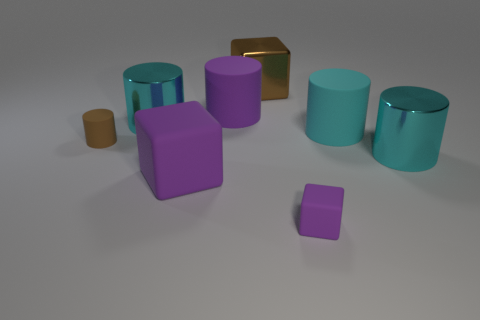How many cyan cylinders have the same material as the big brown thing?
Provide a succinct answer. 2. How many blue shiny things are there?
Keep it short and to the point. 0. Is the size of the shiny cube the same as the shiny thing that is in front of the tiny brown rubber cylinder?
Provide a short and direct response. Yes. There is a tiny thing behind the large object that is right of the big cyan rubber cylinder; what is its material?
Make the answer very short. Rubber. How big is the brown object that is to the right of the small object that is left of the shiny thing left of the brown metal block?
Give a very brief answer. Large. Do the tiny purple matte object and the big rubber object that is in front of the small brown matte object have the same shape?
Your answer should be compact. Yes. What material is the big brown cube?
Offer a very short reply. Metal. How many metallic objects are large cyan objects or purple cubes?
Your answer should be compact. 2. Is the number of brown rubber objects right of the small purple matte thing less than the number of large brown cubes that are behind the brown cube?
Provide a succinct answer. No. There is a brown object on the left side of the rubber block left of the tiny purple matte object; is there a large rubber thing to the right of it?
Keep it short and to the point. Yes. 